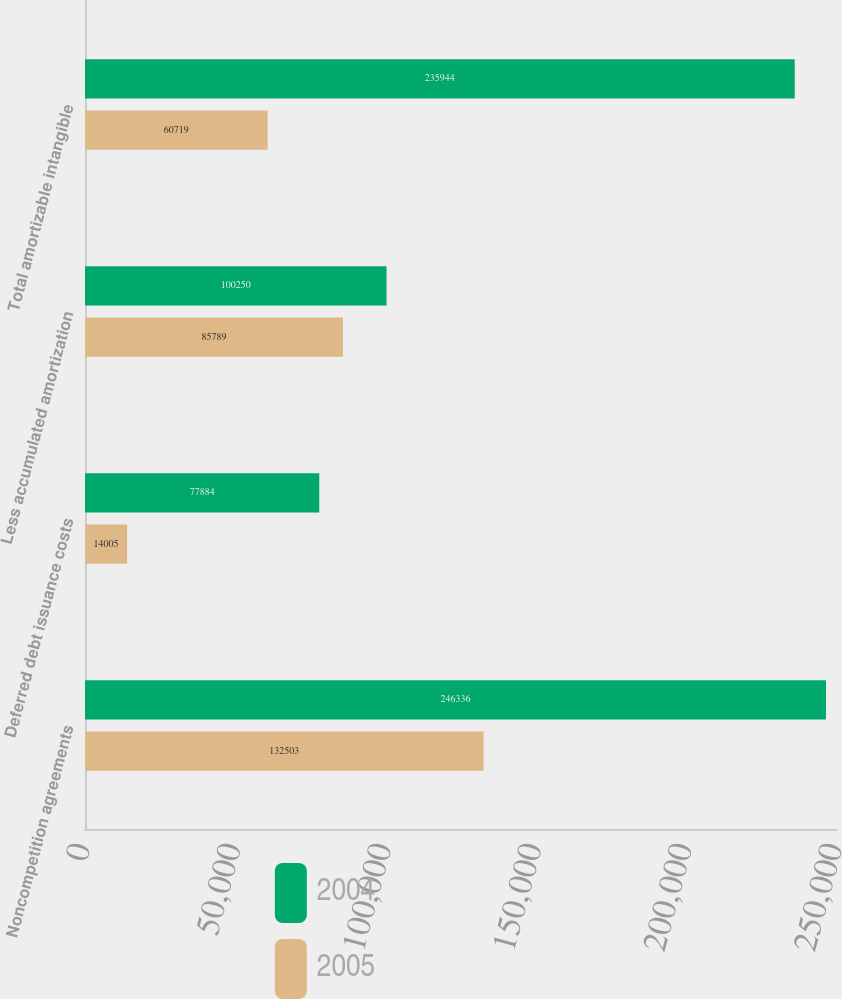<chart> <loc_0><loc_0><loc_500><loc_500><stacked_bar_chart><ecel><fcel>Noncompetition agreements<fcel>Deferred debt issuance costs<fcel>Less accumulated amortization<fcel>Total amortizable intangible<nl><fcel>2004<fcel>246336<fcel>77884<fcel>100250<fcel>235944<nl><fcel>2005<fcel>132503<fcel>14005<fcel>85789<fcel>60719<nl></chart> 